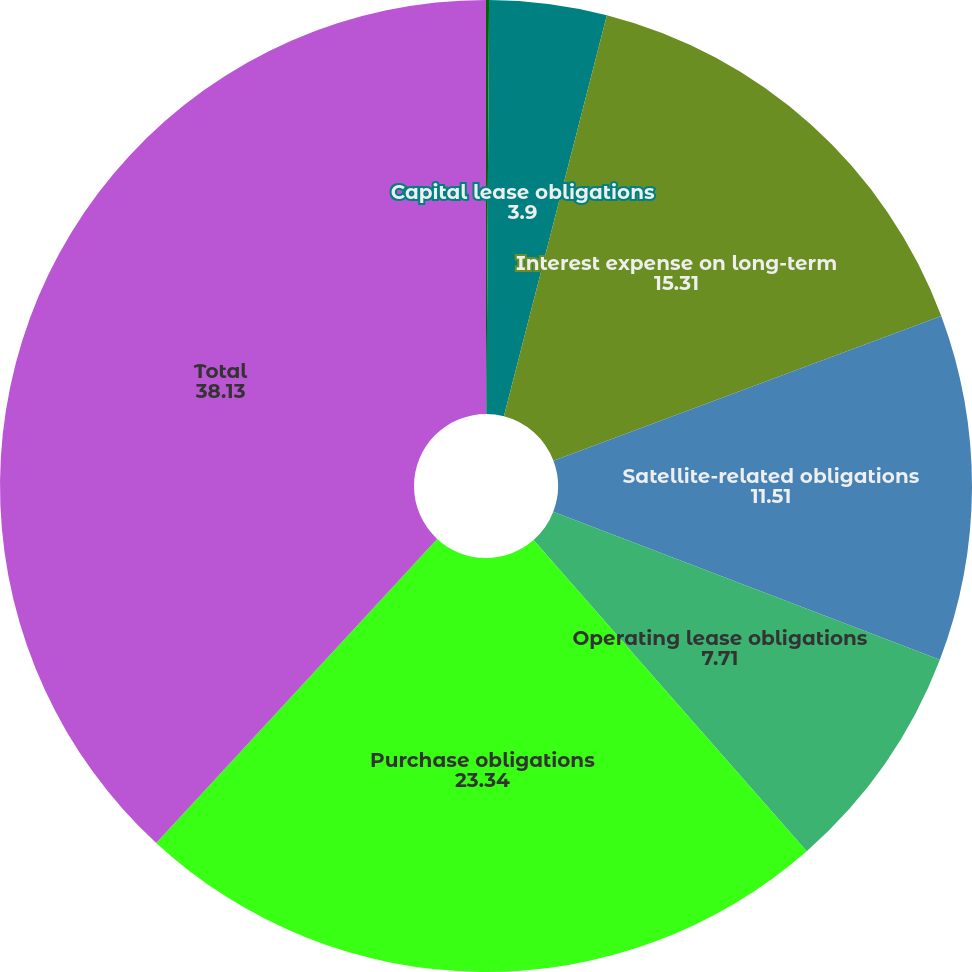Convert chart to OTSL. <chart><loc_0><loc_0><loc_500><loc_500><pie_chart><fcel>Long-term debt obligations<fcel>Capital lease obligations<fcel>Interest expense on long-term<fcel>Satellite-related obligations<fcel>Operating lease obligations<fcel>Purchase obligations<fcel>Total<nl><fcel>0.1%<fcel>3.9%<fcel>15.31%<fcel>11.51%<fcel>7.71%<fcel>23.34%<fcel>38.13%<nl></chart> 